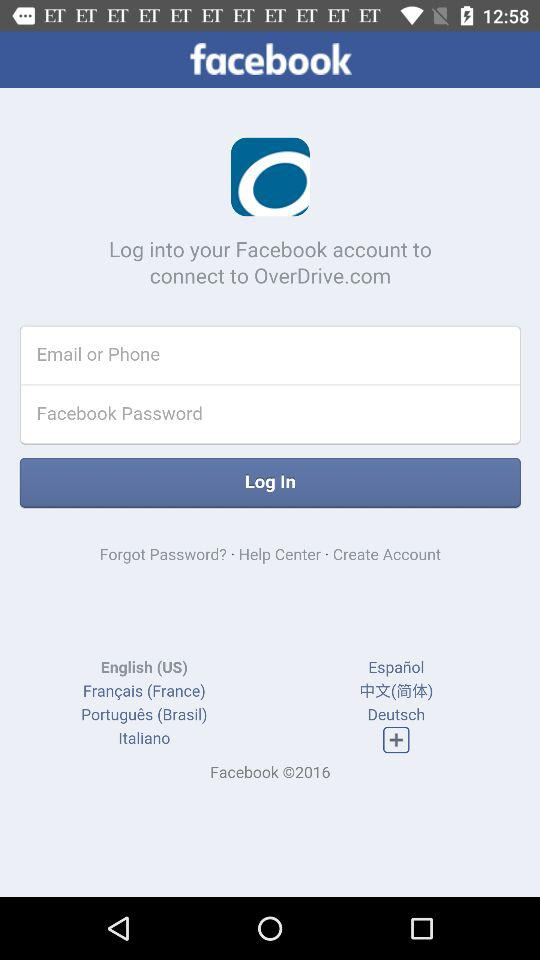Where can we log in to connect to "OverDrive.com"? You can log in to "Facebook". 